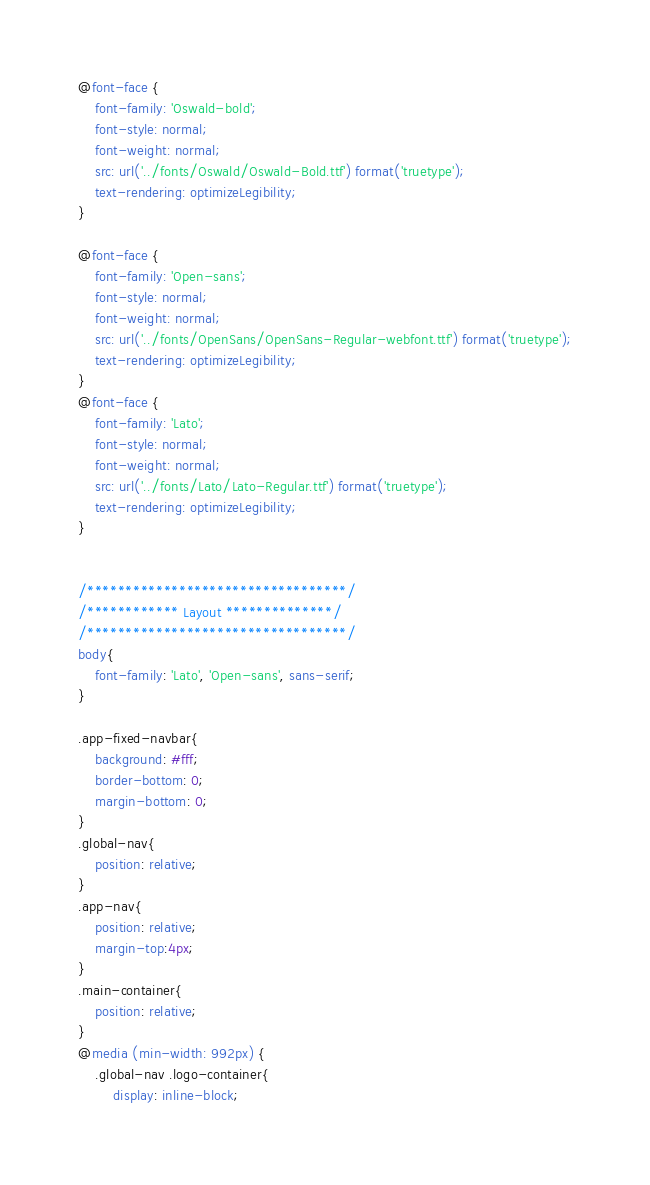Convert code to text. <code><loc_0><loc_0><loc_500><loc_500><_CSS_>
@font-face {
    font-family: 'Oswald-bold';
    font-style: normal;
    font-weight: normal;
    src: url('../fonts/Oswald/Oswald-Bold.ttf') format('truetype');
    text-rendering: optimizeLegibility;
}

@font-face {
    font-family: 'Open-sans';
    font-style: normal;
    font-weight: normal;
    src: url('../fonts/OpenSans/OpenSans-Regular-webfont.ttf') format('truetype');
    text-rendering: optimizeLegibility;
}
@font-face {
    font-family: 'Lato';
    font-style: normal;
    font-weight: normal;
    src: url('../fonts/Lato/Lato-Regular.ttf') format('truetype');
    text-rendering: optimizeLegibility;
}


/**********************************/
/************ Layout **************/
/**********************************/
body{
    font-family: 'Lato', 'Open-sans', sans-serif; 
}

.app-fixed-navbar{
    background: #fff;
    border-bottom: 0;
    margin-bottom: 0;
}
.global-nav{
    position: relative;
}
.app-nav{
    position: relative;
    margin-top:4px;
}
.main-container{
    position: relative;
}
@media (min-width: 992px) {
    .global-nav .logo-container{
        display: inline-block;</code> 